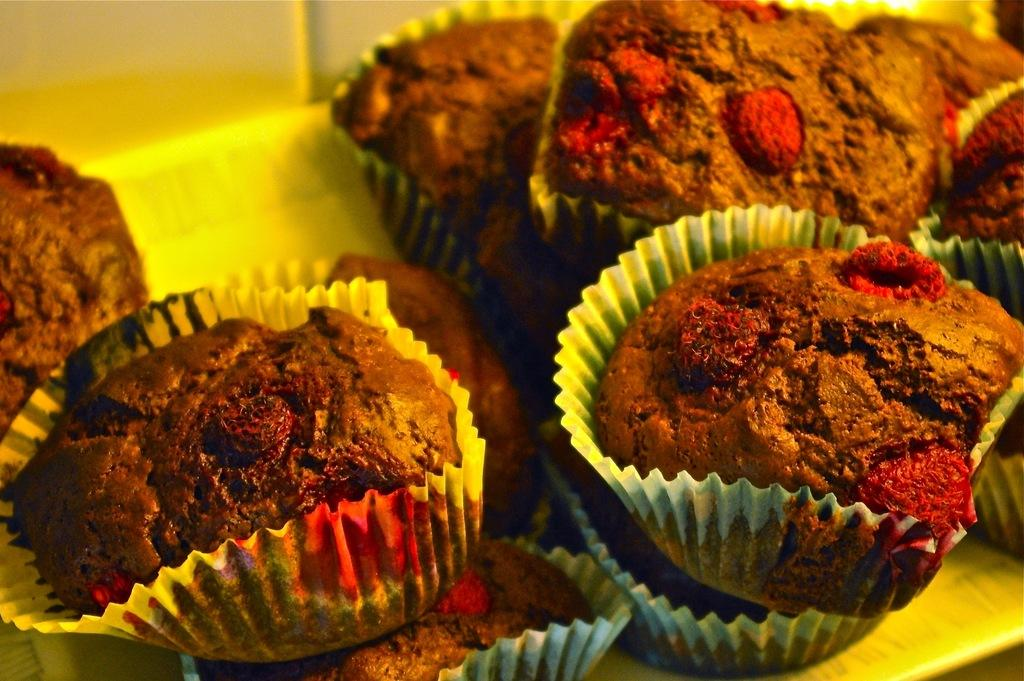What color are the cupcakes in the image? The cupcakes in the image are brown. What type of rhythm does the hen exhibit during the battle in the image? There is no hen or battle present in the image; it only features brown color cupcakes. 